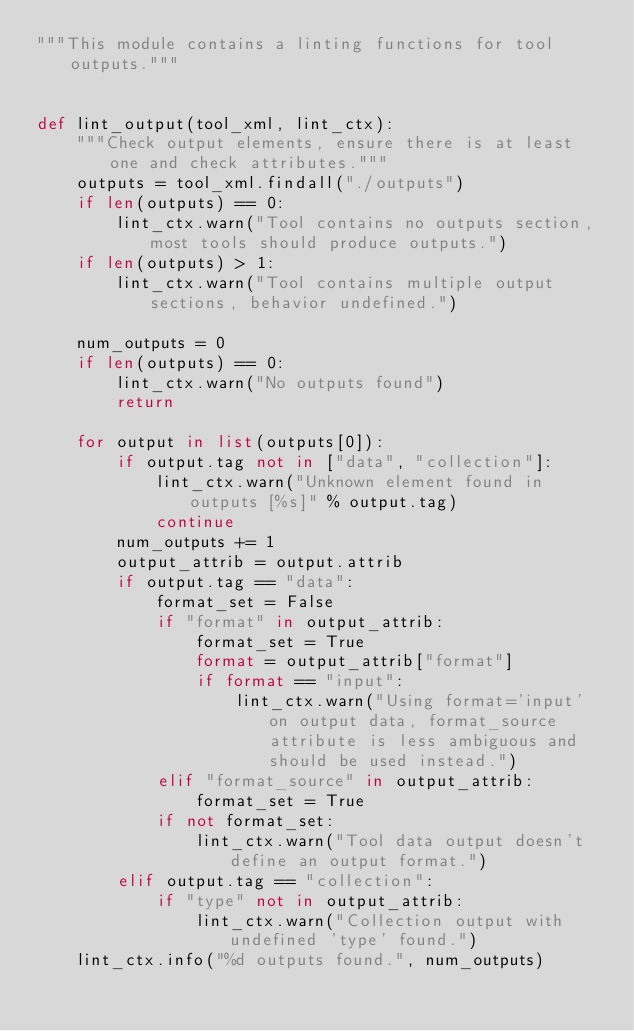<code> <loc_0><loc_0><loc_500><loc_500><_Python_>"""This module contains a linting functions for tool outputs."""


def lint_output(tool_xml, lint_ctx):
    """Check output elements, ensure there is at least one and check attributes."""
    outputs = tool_xml.findall("./outputs")
    if len(outputs) == 0:
        lint_ctx.warn("Tool contains no outputs section, most tools should produce outputs.")
    if len(outputs) > 1:
        lint_ctx.warn("Tool contains multiple output sections, behavior undefined.")

    num_outputs = 0
    if len(outputs) == 0:
        lint_ctx.warn("No outputs found")
        return

    for output in list(outputs[0]):
        if output.tag not in ["data", "collection"]:
            lint_ctx.warn("Unknown element found in outputs [%s]" % output.tag)
            continue
        num_outputs += 1
        output_attrib = output.attrib
        if output.tag == "data":
            format_set = False
            if "format" in output_attrib:
                format_set = True
                format = output_attrib["format"]
                if format == "input":
                    lint_ctx.warn("Using format='input' on output data, format_source attribute is less ambiguous and should be used instead.")
            elif "format_source" in output_attrib:
                format_set = True
            if not format_set:
                lint_ctx.warn("Tool data output doesn't define an output format.")
        elif output.tag == "collection":
            if "type" not in output_attrib:
                lint_ctx.warn("Collection output with undefined 'type' found.")
    lint_ctx.info("%d outputs found.", num_outputs)
</code> 